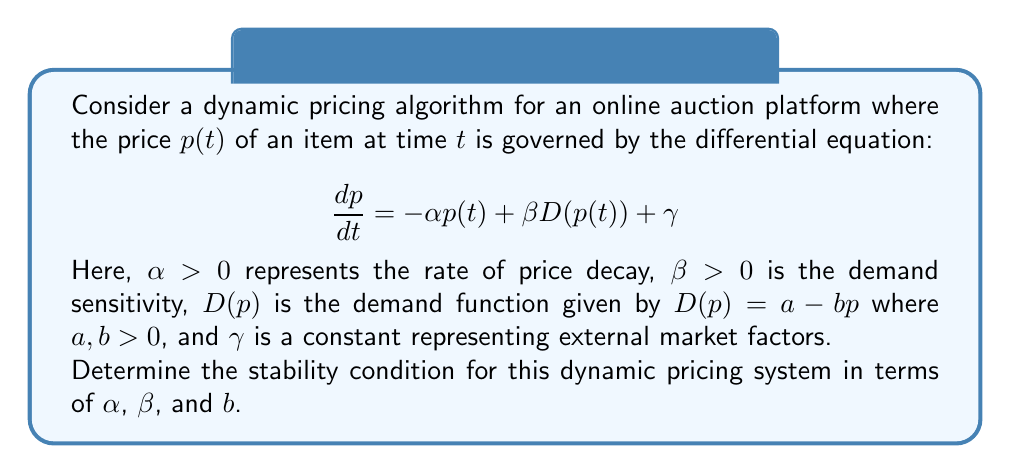Provide a solution to this math problem. To analyze the stability of this dynamic pricing algorithm, we need to follow these steps:

1) First, let's substitute the demand function into the differential equation:

   $$\frac{dp}{dt} = -\alpha p(t) + \beta(a - bp(t)) + \gamma$$

2) Simplify the equation:

   $$\frac{dp}{dt} = -\alpha p(t) + \beta a - \beta b p(t) + \gamma$$
   $$\frac{dp}{dt} = (-\alpha - \beta b)p(t) + (\beta a + \gamma)$$

3) To analyze stability, we need to find the equilibrium point. At equilibrium, $\frac{dp}{dt} = 0$:

   $$0 = (-\alpha - \beta b)p^* + (\beta a + \gamma)$$

   where $p^*$ is the equilibrium price.

4) Solving for $p^*$:

   $$p^* = \frac{\beta a + \gamma}{\alpha + \beta b}$$

5) Now, let's consider a small perturbation around this equilibrium point:

   $$p(t) = p^* + \delta p(t)$$

6) Substitute this into our original differential equation:

   $$\frac{d(p^* + \delta p)}{dt} = (-\alpha - \beta b)(p^* + \delta p) + (\beta a + \gamma)$$

7) The equilibrium terms cancel out, leaving us with:

   $$\frac{d(\delta p)}{dt} = (-\alpha - \beta b)\delta p$$

8) This is a linear first-order differential equation. Its solution is of the form:

   $$\delta p(t) = Ce^{(-\alpha - \beta b)t}$$

   where $C$ is a constant determined by initial conditions.

9) For stability, we need the perturbation to decay over time, which means the exponent must be negative:

   $$-\alpha - \beta b < 0$$

10) Rearranging this inequality gives us our stability condition:

    $$\alpha + \beta b > 0$$

This condition is always satisfied since we defined $\alpha > 0$, $\beta > 0$, and $b > 0$ at the outset.
Answer: The stability condition for the dynamic pricing system is $\alpha + \beta b > 0$, which is always satisfied given the initial conditions that $\alpha > 0$, $\beta > 0$, and $b > 0$. Therefore, the system is always stable. 